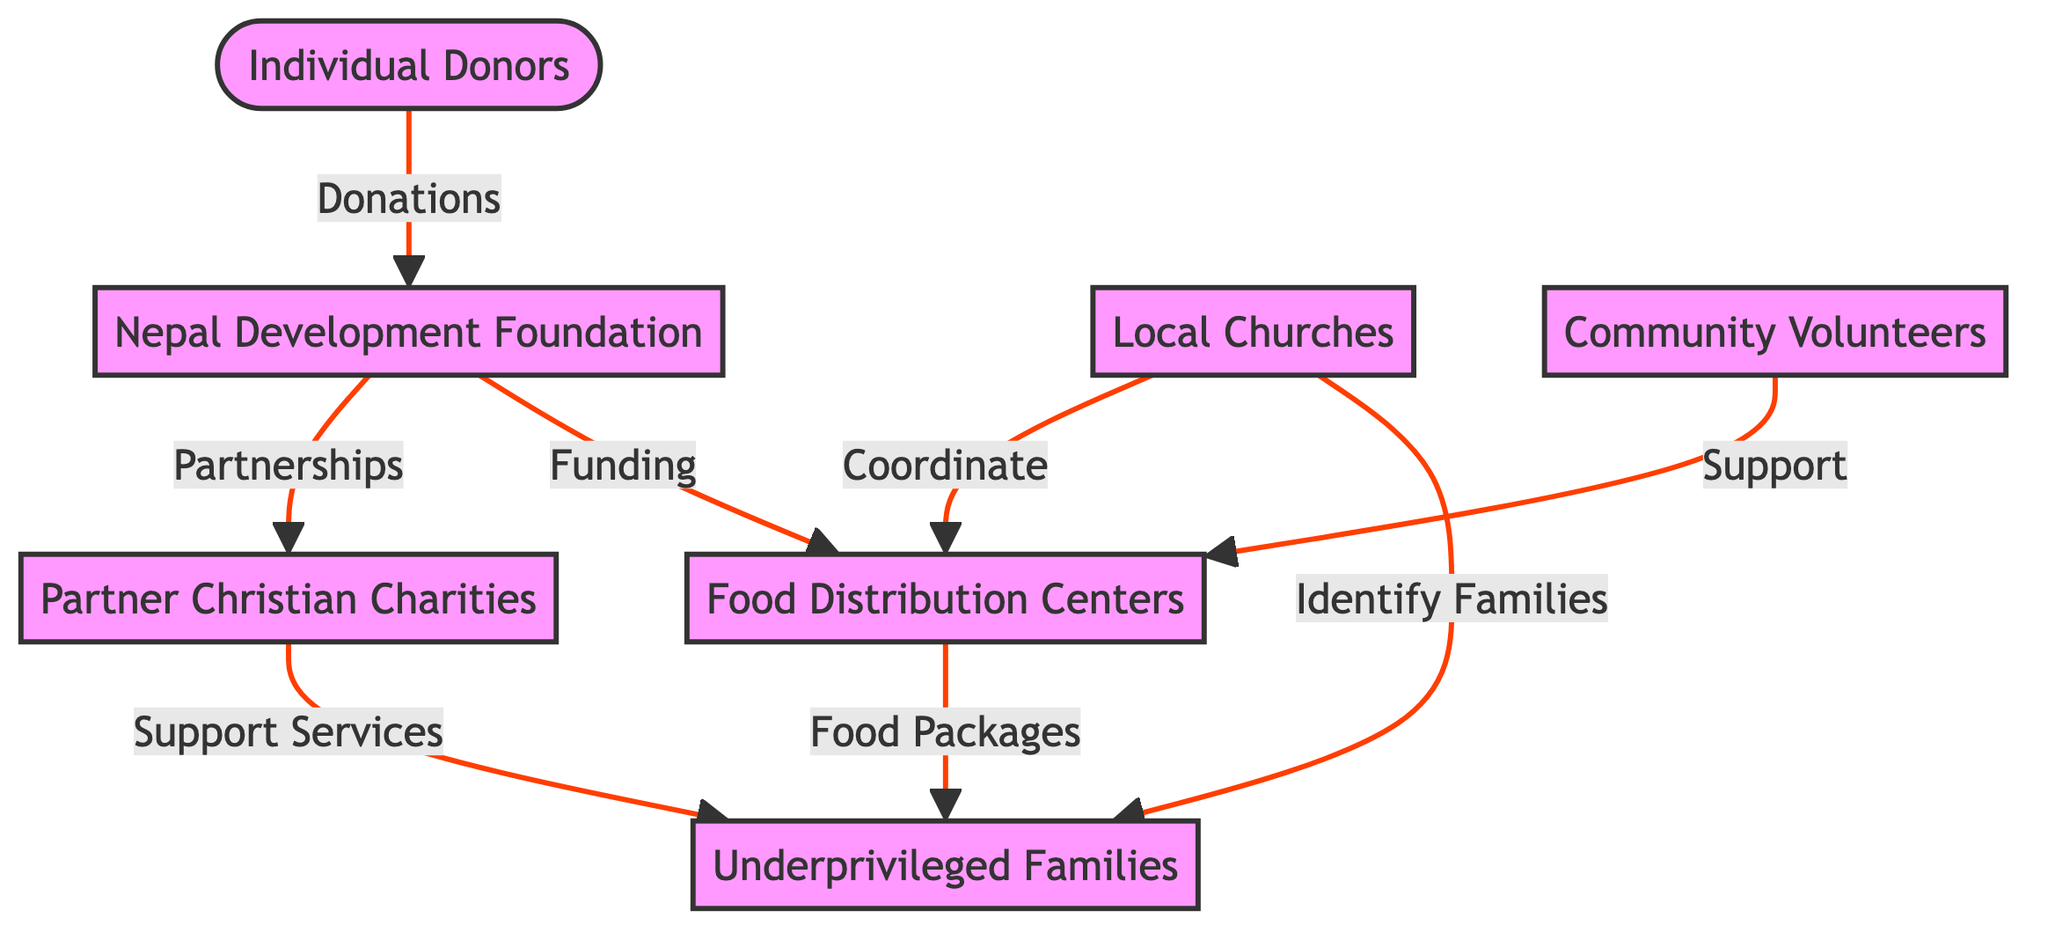What is the role of individual donors in this food distribution chain? Individual donors provide donations that initiate the food distribution chain, as indicated by the arrow from donors to Nepal Development Foundation.
Answer: Donations How many primary nodes are in the diagram? The diagram contains 7 primary nodes (Individual Donors, Nepal Development Foundation, Food Distribution Centers, Partner Christian Charities, Local Churches, Underprivileged Families, Community Volunteers).
Answer: 7 Which entity is responsible for identifying underprivileged families? Local churches are responsible for identifying underprivileged families, as shown by the direct link from churches to underprivileged families in the diagram.
Answer: Local Churches What type of support do community volunteers provide? Community volunteers provide support to Food Distribution Centers, indicated by their direct connection in the diagram.
Answer: Support What is the relationship between Nepal Development Foundation and Partner Christian Charities? Nepal Development Foundation has partnerships with Partner Christian Charities, as shown by the directed edge indicating partnerships from NDF to PCC.
Answer: Partnerships How do Food Distribution Centers distribute food packages? Food Distribution Centers distribute food packages directly to underprivileged families, as indicated by the arrow from fdc to underprivileged.
Answer: Food Packages Which node has a supporting role to the underprivileged families in addition to local churches? Partner Christian Charities has a supporting role to underprivileged families, as indicated by the arrow showing support services from PCC to underprivileged families.
Answer: Support Services What type of center receives funding from the Nepal Development Foundation? Food Distribution Centers receive funding from the Nepal Development Foundation, as represented by the directed edge between these nodes.
Answer: Food Distribution Centers 